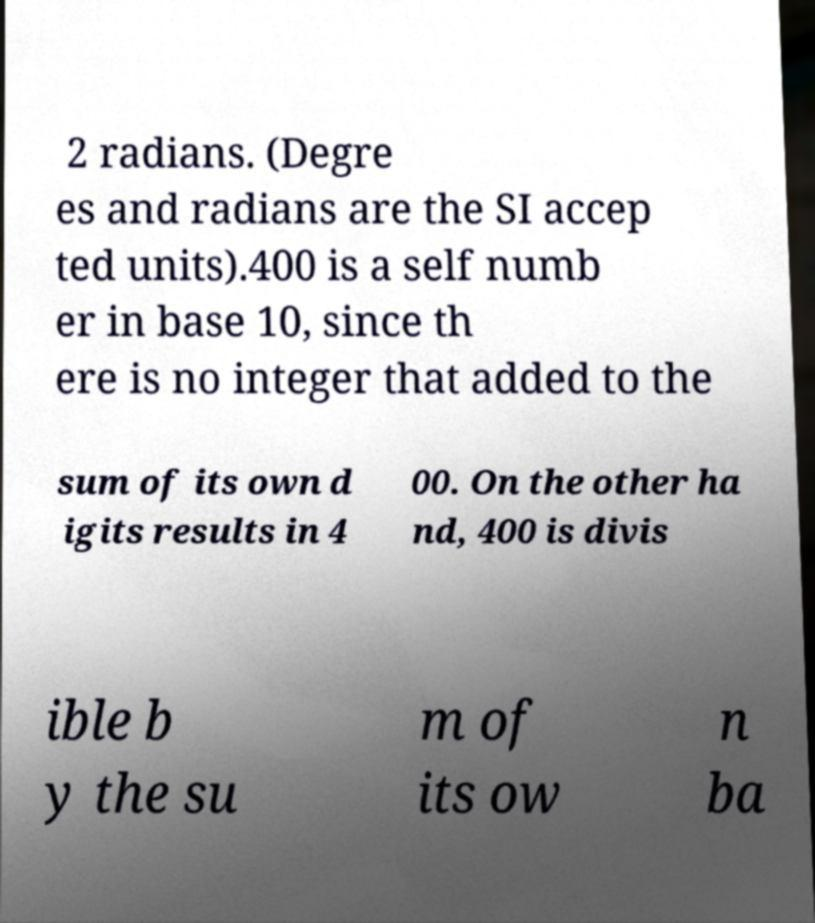Could you extract and type out the text from this image? 2 radians. (Degre es and radians are the SI accep ted units).400 is a self numb er in base 10, since th ere is no integer that added to the sum of its own d igits results in 4 00. On the other ha nd, 400 is divis ible b y the su m of its ow n ba 